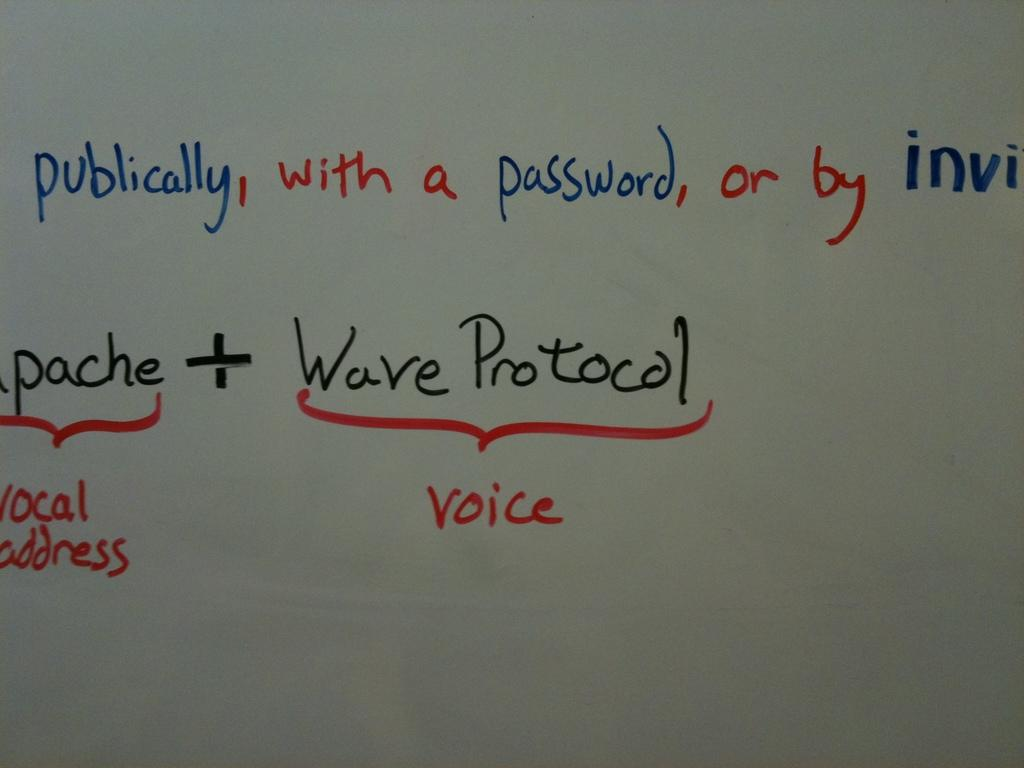<image>
Present a compact description of the photo's key features. A white board with writing on in, including the phrase "with a password" and "wave protocol". 